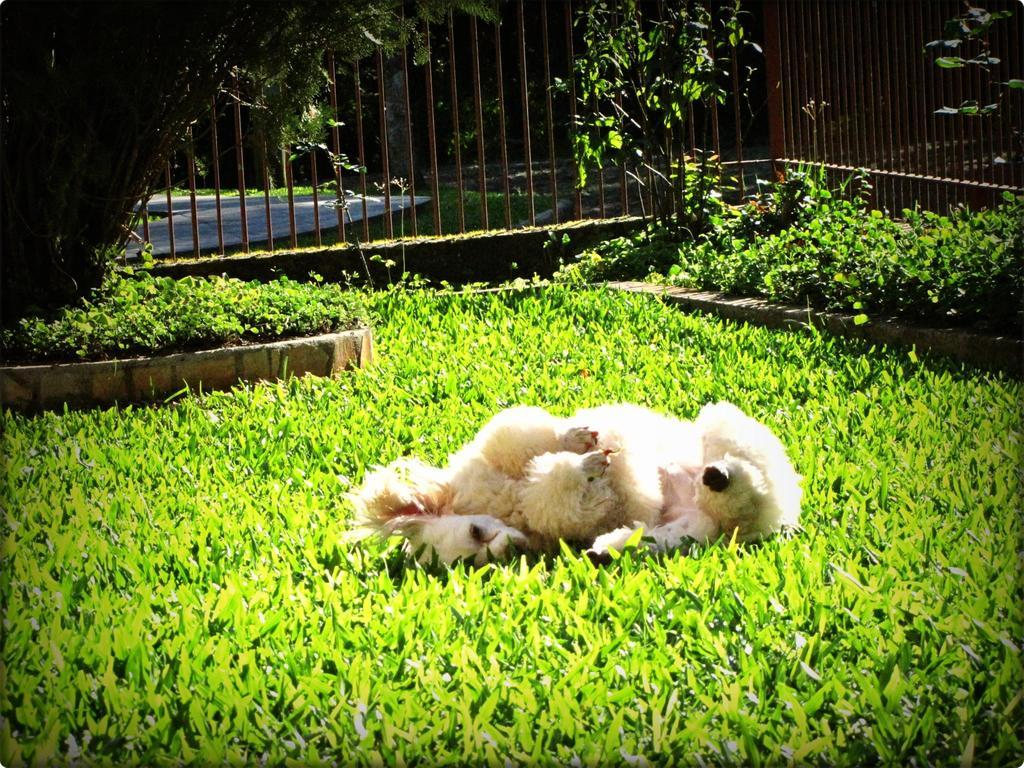How many dogs are in the image? There are two dogs in the image. What are the dogs doing in the image? The dogs are lying on the grass. What can be seen in the background of the image? There are plants, fencing, a road, and trees in the background of the image. What type of wren can be seen flying over the dogs in the image? There is no wren present in the image; it only features two dogs lying on the grass and various background elements. 